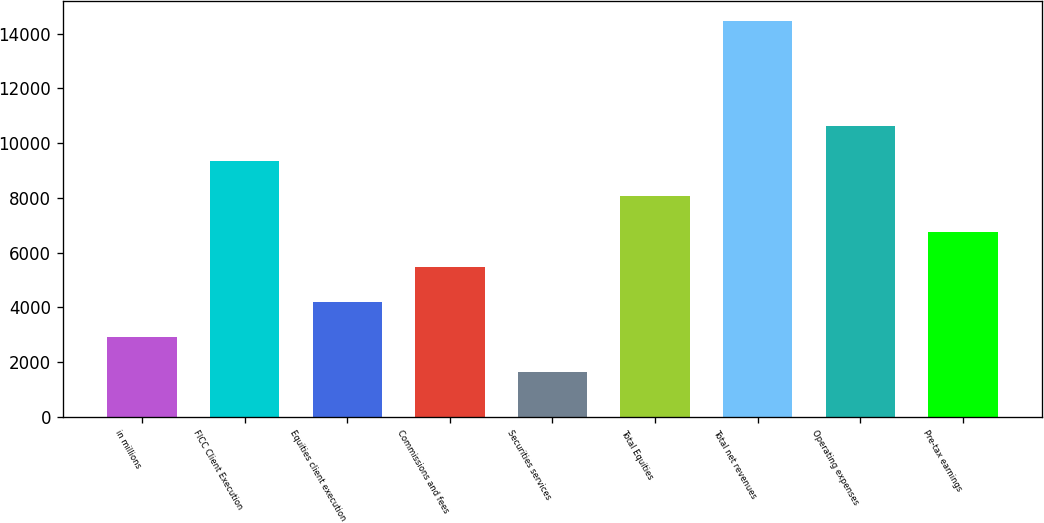<chart> <loc_0><loc_0><loc_500><loc_500><bar_chart><fcel>in millions<fcel>FICC Client Execution<fcel>Equities client execution<fcel>Commissions and fees<fcel>Securities services<fcel>Total Equities<fcel>Total net revenues<fcel>Operating expenses<fcel>Pre-tax earnings<nl><fcel>2921.8<fcel>9335.8<fcel>4204.6<fcel>5487.4<fcel>1639<fcel>8053<fcel>14467<fcel>10618.6<fcel>6770.2<nl></chart> 